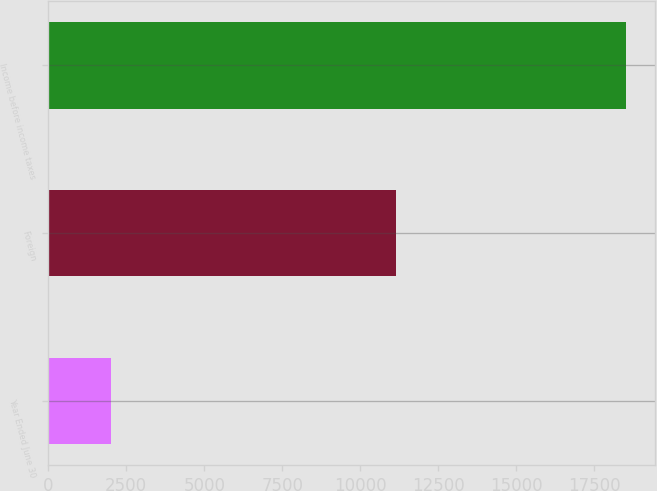Convert chart to OTSL. <chart><loc_0><loc_0><loc_500><loc_500><bar_chart><fcel>Year Ended June 30<fcel>Foreign<fcel>Income before income taxes<nl><fcel>2015<fcel>11144<fcel>18507<nl></chart> 